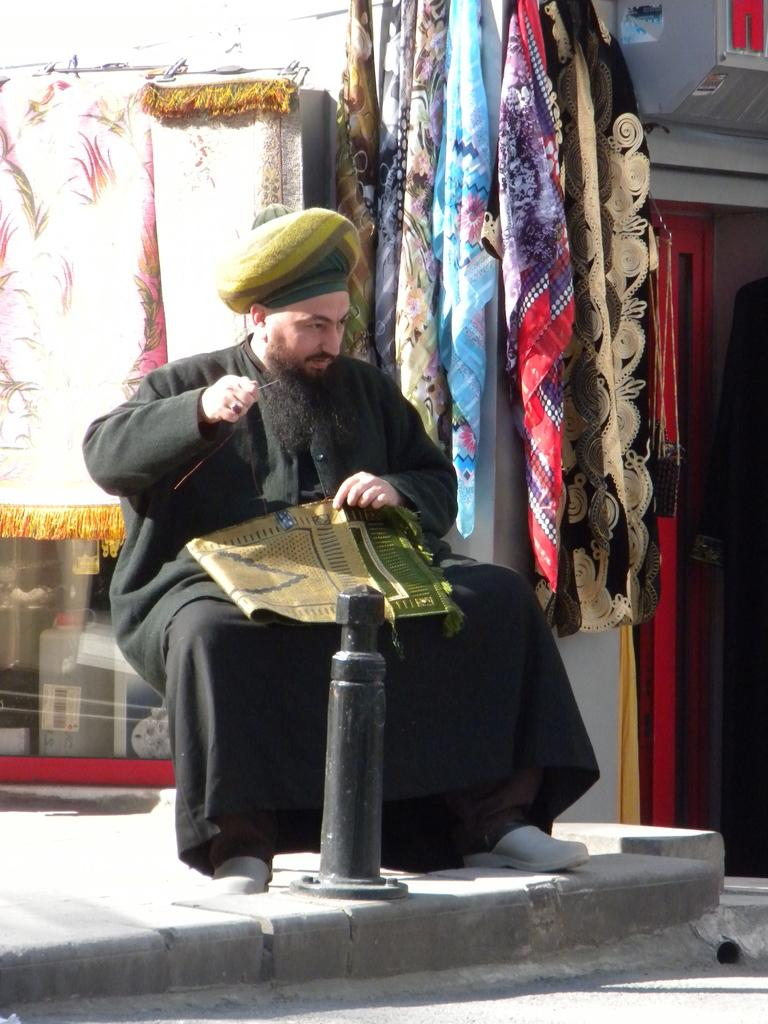What can be seen in the image? There is a person in the image. Can you describe the person's attire? The person is wearing a cap and a black dress. What is the person holding in his hand? The person is holding a cloth in his hand. What is present in the foreground of the image? There is a pole in the foreground of the image. What can be seen in the background of the image? There is a group of clothes in the background of the image. What type of metal can be seen growing from the ground in the image? There is no metal visible in the image, nor is there any indication of it growing from the ground. 